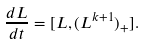<formula> <loc_0><loc_0><loc_500><loc_500>\frac { d L } { d t } = [ L , ( L ^ { k + 1 } ) _ { + } ] .</formula> 